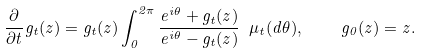<formula> <loc_0><loc_0><loc_500><loc_500>\frac { \partial } { \partial t } g _ { t } ( z ) = g _ { t } ( z ) \int _ { 0 } ^ { 2 \pi } \frac { e ^ { i \theta } + g _ { t } ( z ) } { e ^ { i \theta } - g _ { t } ( z ) } \ \mu _ { t } ( d \theta ) , \quad g _ { 0 } ( z ) = z .</formula> 